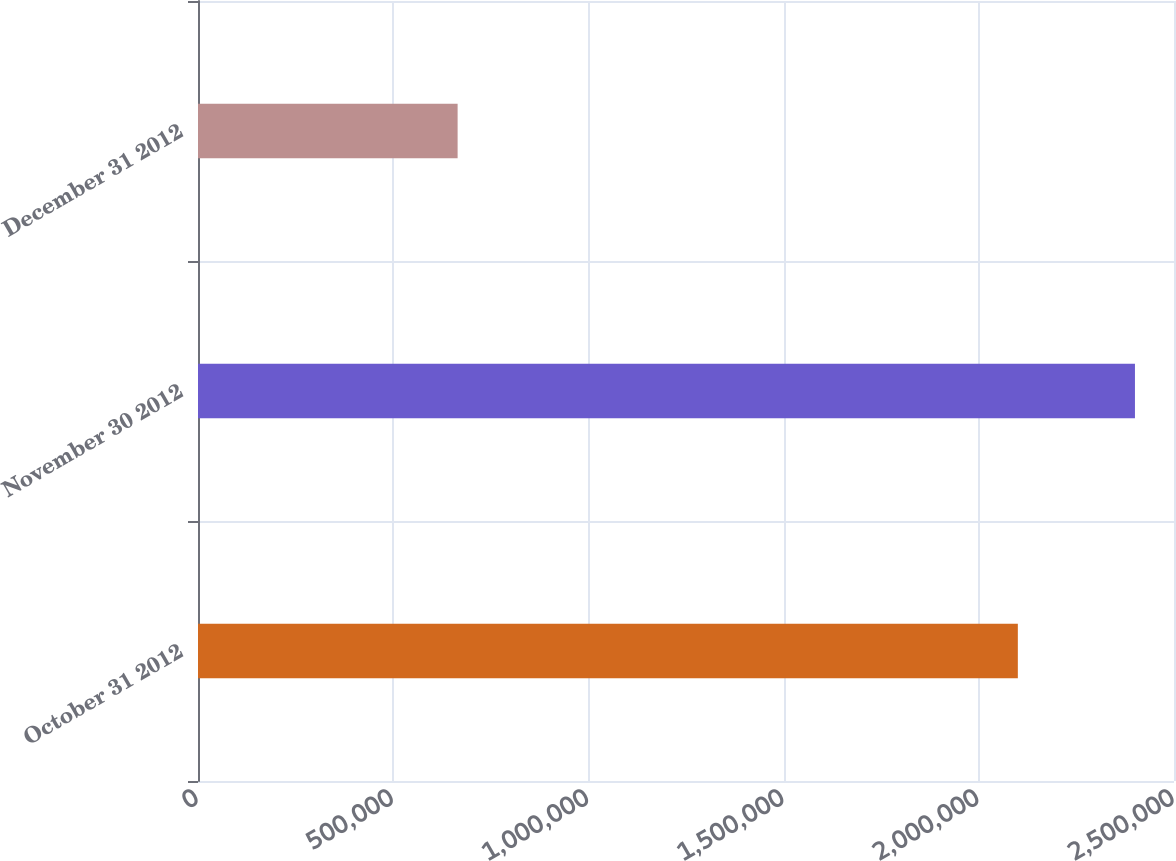<chart> <loc_0><loc_0><loc_500><loc_500><bar_chart><fcel>October 31 2012<fcel>November 30 2012<fcel>December 31 2012<nl><fcel>2.1e+06<fcel>2.4e+06<fcel>665000<nl></chart> 